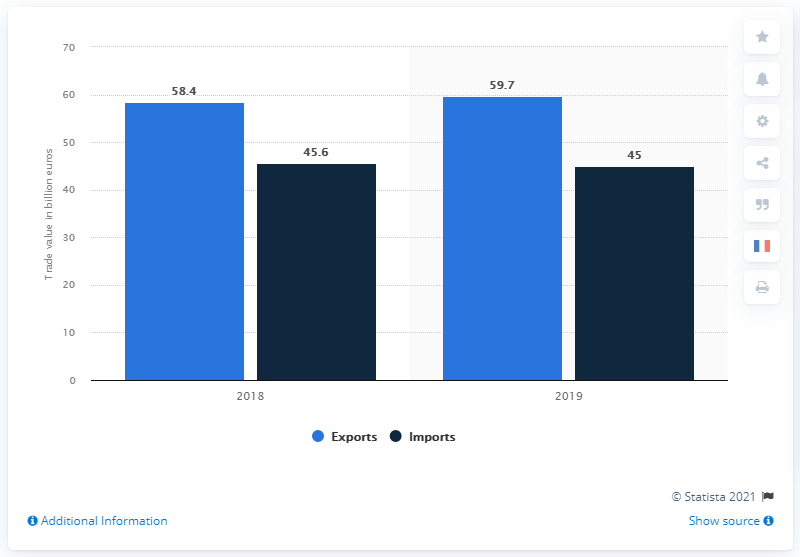List a handful of essential elements in this visual. In 2019, the import value of chemicals, cosmetics, and perfumes was approximately 45. According to the statistics provided by the French Ministry of Economy and Finance, the value of French exports of chemicals, cosmetics and perfumes in 2019 was 59.7 billion euros. 